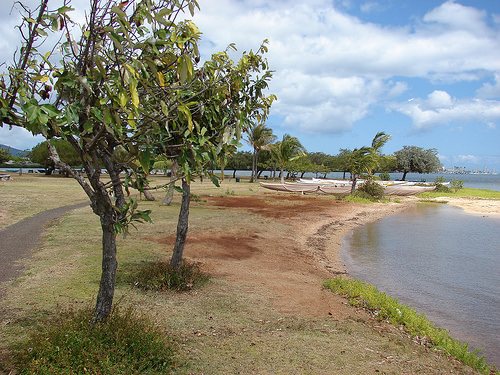<image>
Is the tree above the bank? No. The tree is not positioned above the bank. The vertical arrangement shows a different relationship. 